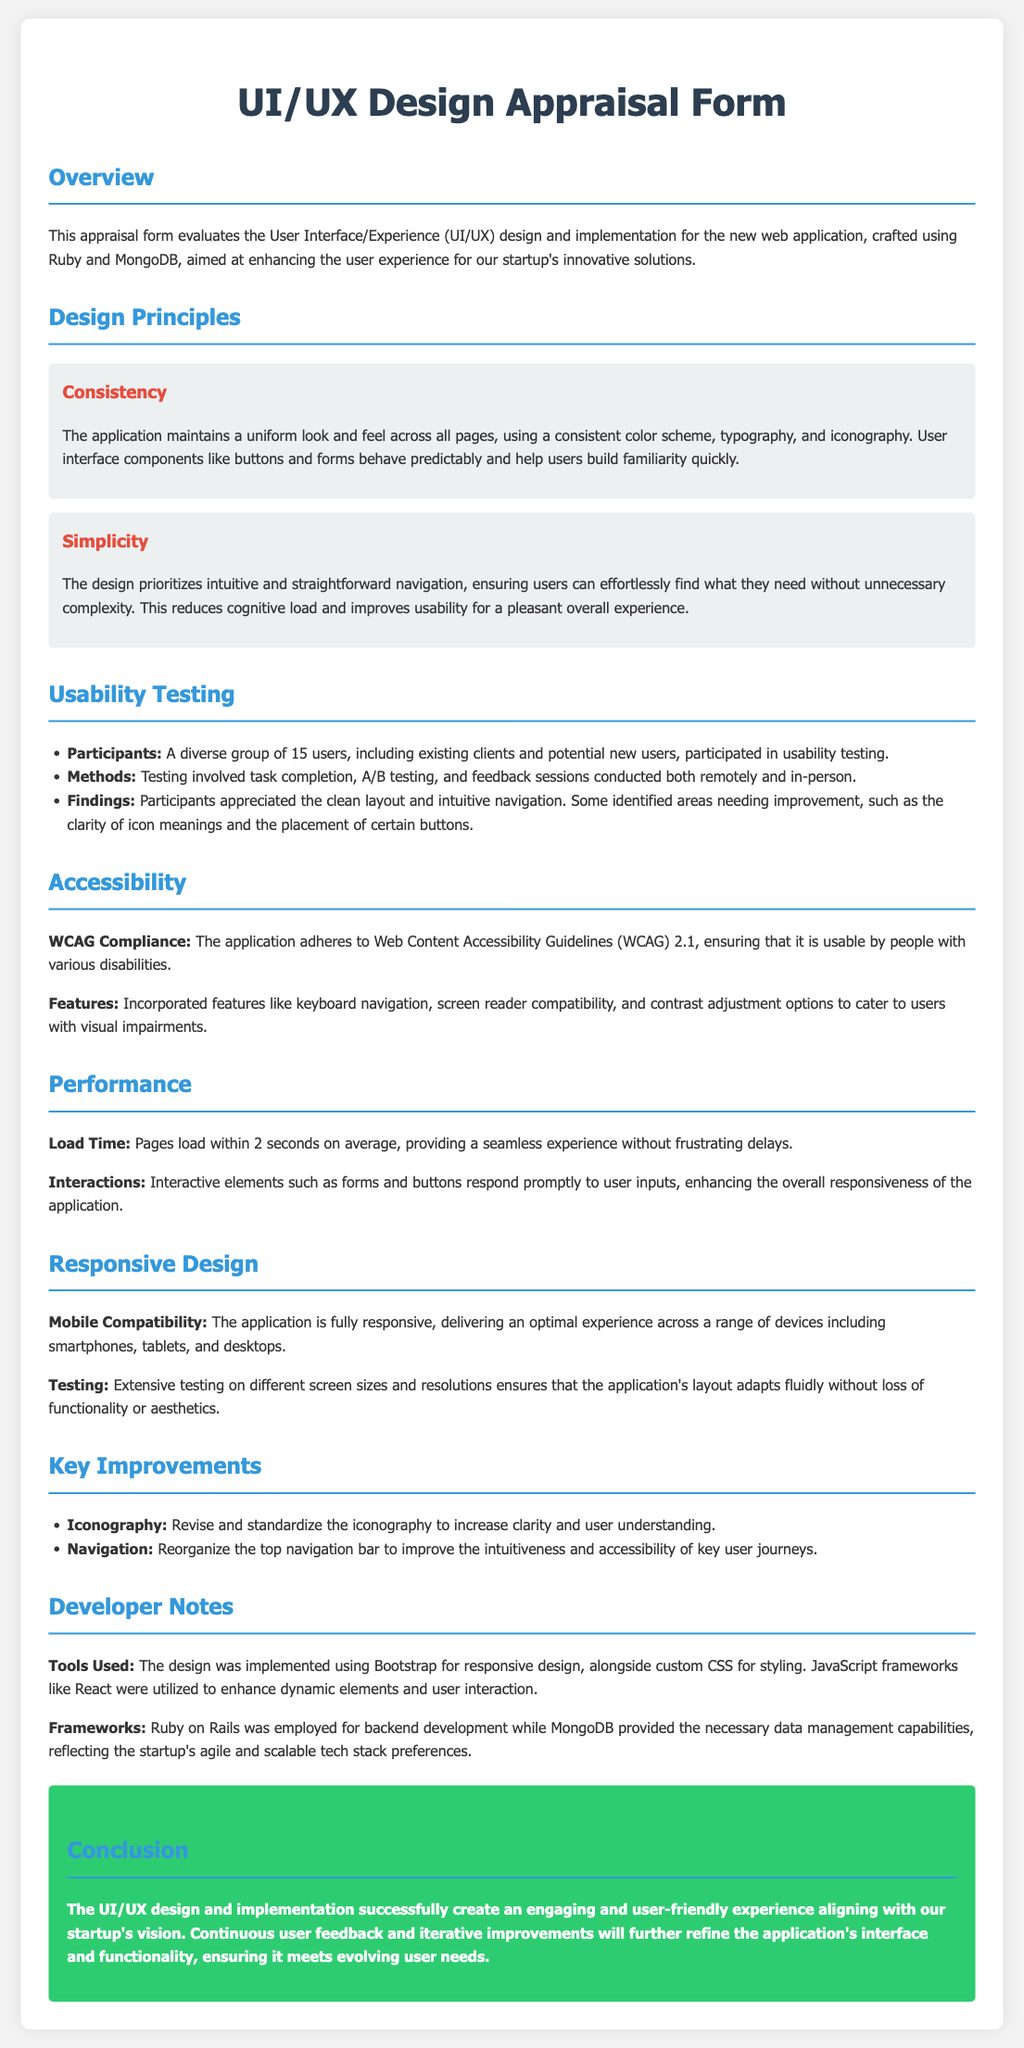What is the average load time for pages? The average load time for pages is mentioned in the performance section of the document.
Answer: 2 seconds How many users participated in usability testing? The number of participants in the usability testing is listed under usability testing section.
Answer: 15 users What type of guidelines does the application adhere to for accessibility? The guidelines followed for accessibility are specified in the accessibility section.
Answer: WCAG 2.1 Which tools were used for responsive design? The tools used for responsive design are stated in the developer notes section.
Answer: Bootstrap What is a key improvement suggested for iconography? The suggested key improvement for iconography is outlined in the key improvements section.
Answer: Revise and standardize What framework was employed for backend development? The framework used for backend development is indicated in the developer notes section.
Answer: Ruby on Rails What does the design prioritize according to the simplicity principle? The principle of simplicity focuses on a specific aspect of navigation as described in the design principles section.
Answer: Intuitive and straightforward navigation What type of testing was conducted for usability? The testing methods undertaken for usability are outlined in the usability testing section.
Answer: Task completion, A/B testing, and feedback sessions Which programming language and database are mentioned for building the application? The programming language and database utilized in building the application are indicated in the overview and developer notes.
Answer: Ruby and MongoDB 